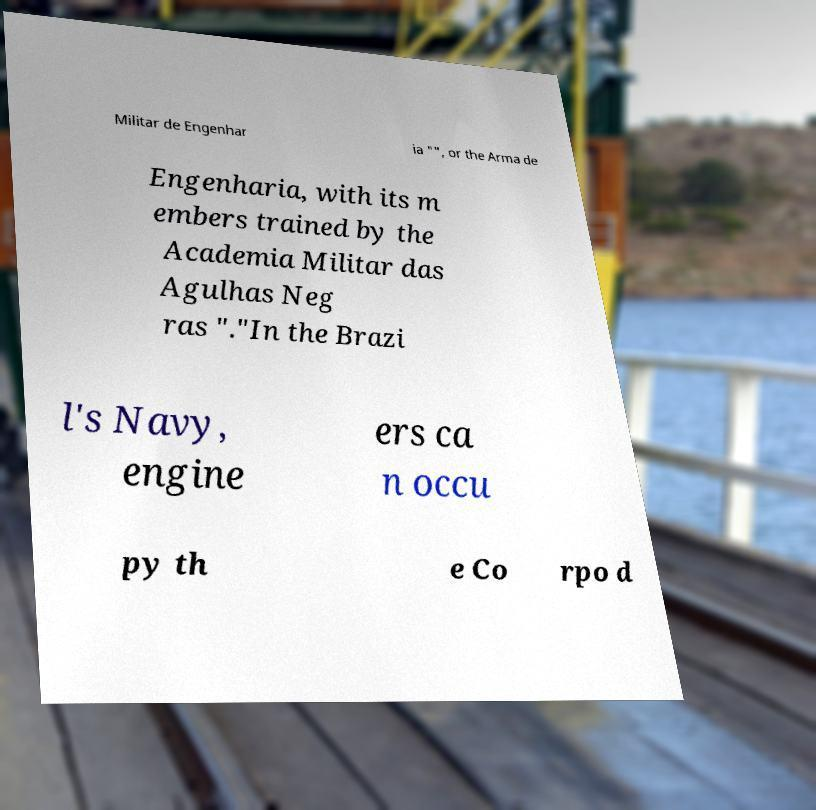Could you extract and type out the text from this image? Militar de Engenhar ia "", or the Arma de Engenharia, with its m embers trained by the Academia Militar das Agulhas Neg ras "."In the Brazi l's Navy, engine ers ca n occu py th e Co rpo d 